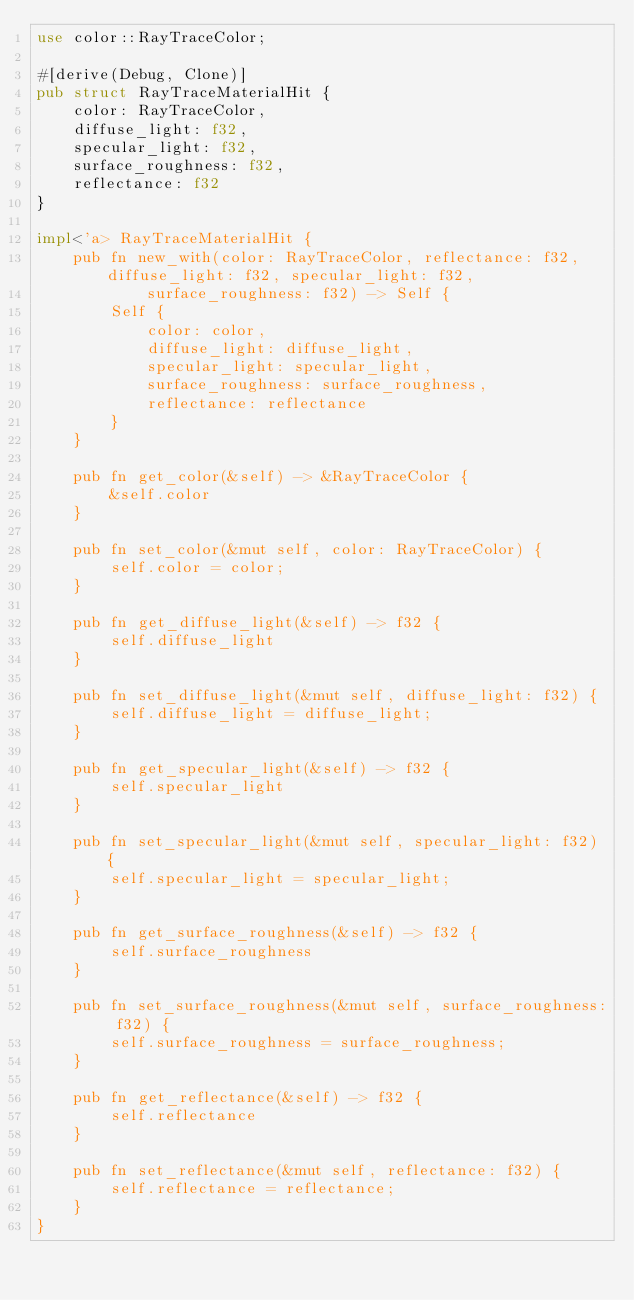Convert code to text. <code><loc_0><loc_0><loc_500><loc_500><_Rust_>use color::RayTraceColor;

#[derive(Debug, Clone)]
pub struct RayTraceMaterialHit {
	color: RayTraceColor,
	diffuse_light: f32,
	specular_light: f32,
	surface_roughness: f32,
	reflectance: f32
}

impl<'a> RayTraceMaterialHit {
	pub fn new_with(color: RayTraceColor, reflectance: f32, diffuse_light: f32, specular_light: f32,
			surface_roughness: f32) -> Self {
		Self {
			color: color,
			diffuse_light: diffuse_light,
			specular_light: specular_light,
			surface_roughness: surface_roughness,
			reflectance: reflectance
		}
	}

	pub fn get_color(&self) -> &RayTraceColor {
		&self.color
	}

	pub fn set_color(&mut self, color: RayTraceColor) {
		self.color = color;
	}

	pub fn get_diffuse_light(&self) -> f32 {
		self.diffuse_light
	}

	pub fn set_diffuse_light(&mut self, diffuse_light: f32) {
		self.diffuse_light = diffuse_light;
	}

	pub fn get_specular_light(&self) -> f32 {
		self.specular_light
	}

	pub fn set_specular_light(&mut self, specular_light: f32) {
		self.specular_light = specular_light;
	}

	pub fn get_surface_roughness(&self) -> f32 {
		self.surface_roughness
	}

	pub fn set_surface_roughness(&mut self, surface_roughness: f32) {
		self.surface_roughness = surface_roughness;
	}

	pub fn get_reflectance(&self) -> f32 {
		self.reflectance
	}

	pub fn set_reflectance(&mut self, reflectance: f32) {
		self.reflectance = reflectance;
	}
}
</code> 